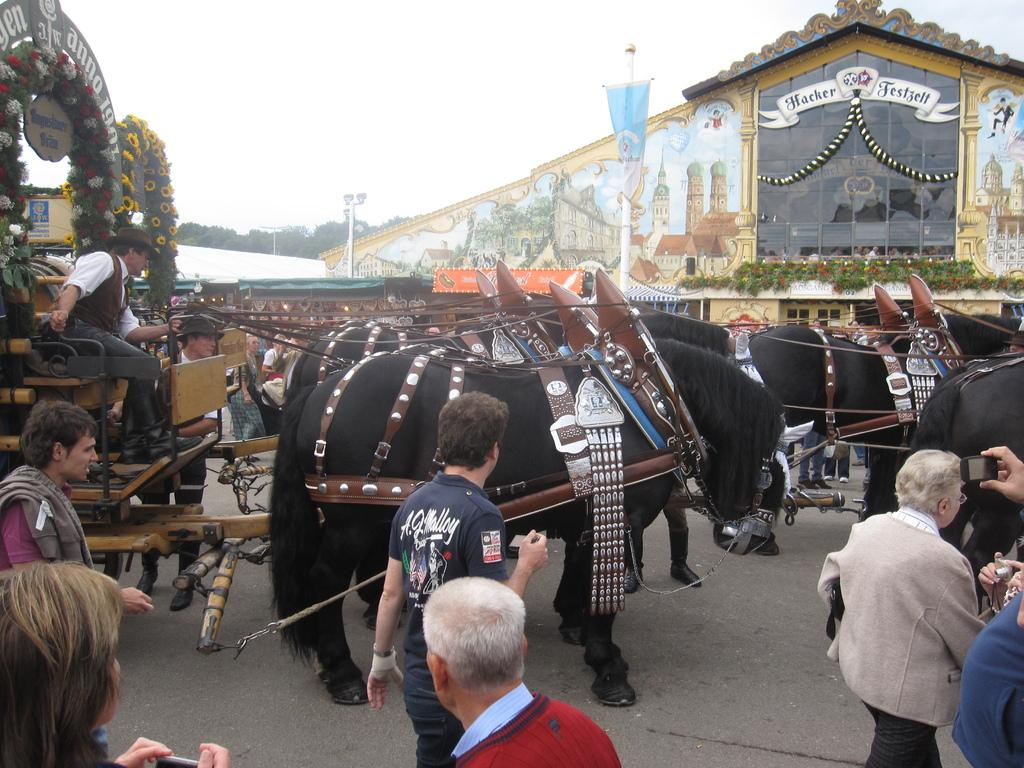What type of transportation is depicted in the image? There are animal carriages in the image. Who is using the animal carriages? People are sitting on the animal carriages. What else is happening on the road in the image? There are people walking on the road in the image. What level of heat can be felt from the animal carriages in the image? There is no indication of heat or temperature in the image, so it cannot be determined. 